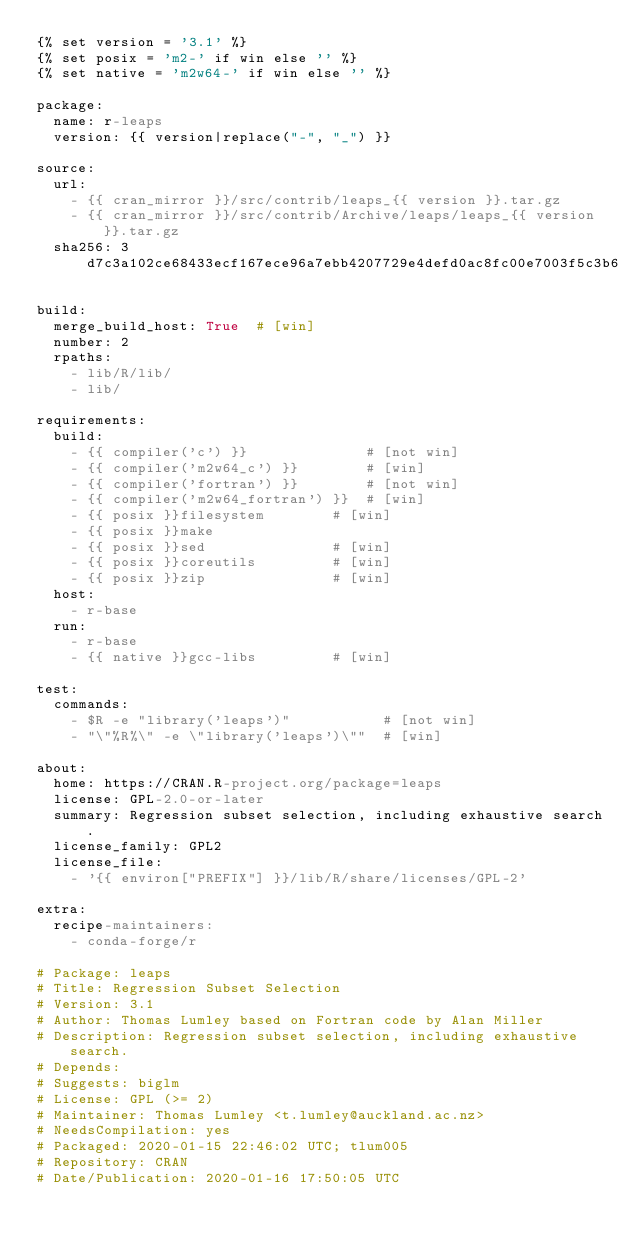<code> <loc_0><loc_0><loc_500><loc_500><_YAML_>{% set version = '3.1' %}
{% set posix = 'm2-' if win else '' %}
{% set native = 'm2w64-' if win else '' %}

package:
  name: r-leaps
  version: {{ version|replace("-", "_") }}

source:
  url:
    - {{ cran_mirror }}/src/contrib/leaps_{{ version }}.tar.gz
    - {{ cran_mirror }}/src/contrib/Archive/leaps/leaps_{{ version }}.tar.gz
  sha256: 3d7c3a102ce68433ecf167ece96a7ebb4207729e4defd0ac8fc00e7003f5c3b6

build:
  merge_build_host: True  # [win]
  number: 2
  rpaths:
    - lib/R/lib/
    - lib/

requirements:
  build:
    - {{ compiler('c') }}              # [not win]
    - {{ compiler('m2w64_c') }}        # [win]
    - {{ compiler('fortran') }}        # [not win]
    - {{ compiler('m2w64_fortran') }}  # [win]
    - {{ posix }}filesystem        # [win]
    - {{ posix }}make
    - {{ posix }}sed               # [win]
    - {{ posix }}coreutils         # [win]
    - {{ posix }}zip               # [win]
  host:
    - r-base
  run:
    - r-base
    - {{ native }}gcc-libs         # [win]

test:
  commands:
    - $R -e "library('leaps')"           # [not win]
    - "\"%R%\" -e \"library('leaps')\""  # [win]

about:
  home: https://CRAN.R-project.org/package=leaps
  license: GPL-2.0-or-later
  summary: Regression subset selection, including exhaustive search.
  license_family: GPL2
  license_file:
    - '{{ environ["PREFIX"] }}/lib/R/share/licenses/GPL-2'

extra:
  recipe-maintainers:
    - conda-forge/r

# Package: leaps
# Title: Regression Subset Selection
# Version: 3.1
# Author: Thomas Lumley based on Fortran code by Alan Miller
# Description: Regression subset selection, including exhaustive search.
# Depends:
# Suggests: biglm
# License: GPL (>= 2)
# Maintainer: Thomas Lumley <t.lumley@auckland.ac.nz>
# NeedsCompilation: yes
# Packaged: 2020-01-15 22:46:02 UTC; tlum005
# Repository: CRAN
# Date/Publication: 2020-01-16 17:50:05 UTC
</code> 